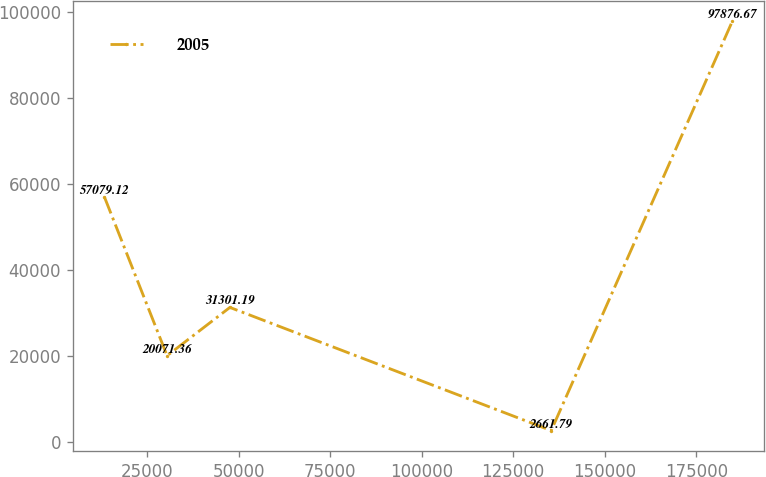Convert chart. <chart><loc_0><loc_0><loc_500><loc_500><line_chart><ecel><fcel>2005<nl><fcel>13289.9<fcel>57079.1<nl><fcel>30449.5<fcel>20071.4<nl><fcel>47609.2<fcel>31301.2<nl><fcel>135390<fcel>2661.79<nl><fcel>184886<fcel>97876.7<nl></chart> 